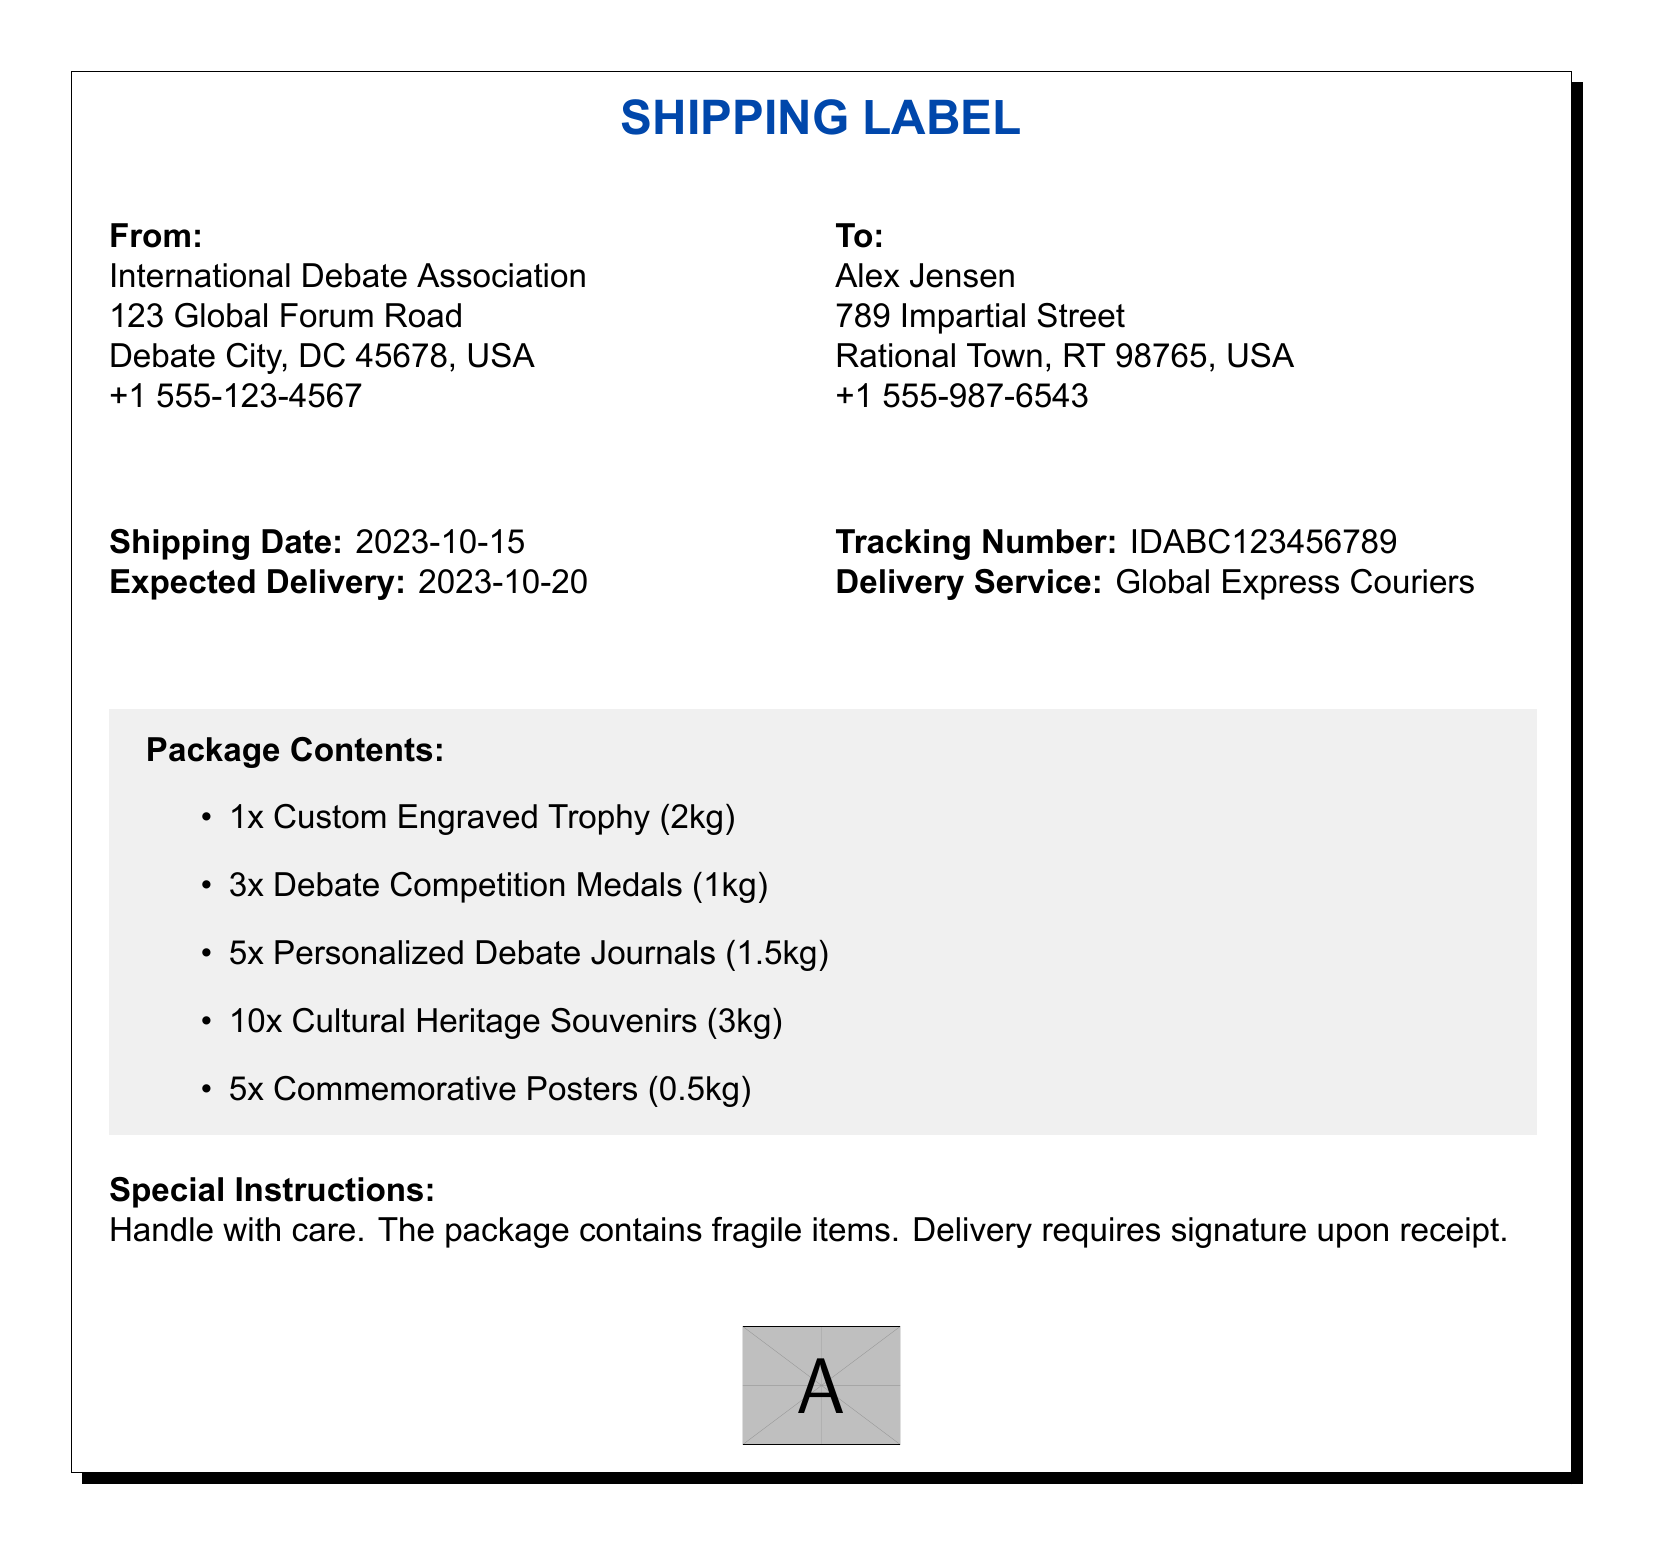What is the shipping date? The shipping date is specified in the document as the day the package is sent, which is stated clearly.
Answer: 2023-10-15 What is the expected delivery date? The expected delivery date is the date when the package is anticipated to arrive, found in the document.
Answer: 2023-10-20 Who is the sender? The sender's name and organization are provided in the 'From' section of the document.
Answer: International Debate Association What items are included in the package? The document lists the contents of the package, providing specific details about the items included.
Answer: 1x Custom Engraved Trophy, 3x Debate Competition Medals, 5x Personalized Debate Journals, 10x Cultural Heritage Souvenirs, 5x Commemorative Posters How many medals are in the package? The document specifies the number of medals included in the package under the 'Package Contents' section.
Answer: 3x What is the tracking number? The tracking number is provided in the document, which allows for tracking the shipment status.
Answer: IDABC123456789 What special instruction is noted for the delivery? The document includes specific handling instructions for the delivery of the package.
Answer: Handle with care What is the total weight of the package? The total weight is the sum of all individual item weights in the package, as indicated in the document.
Answer: 8.0kg Who is the recipient? The 'To' section of the document provides the name of the person receiving the package.
Answer: Alex Jensen 